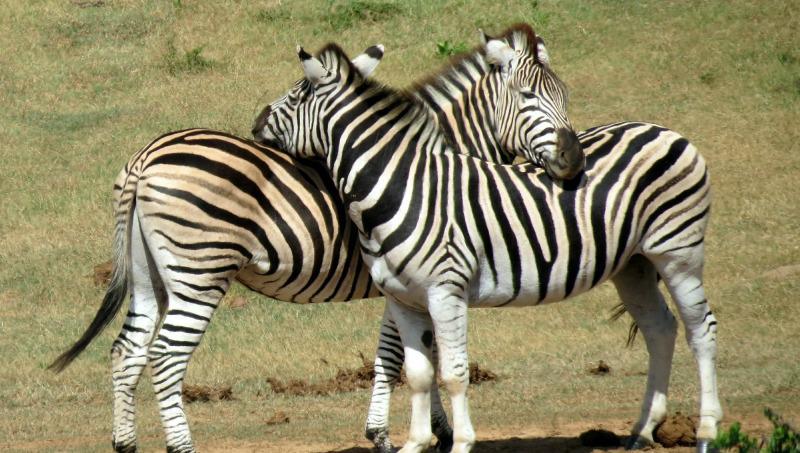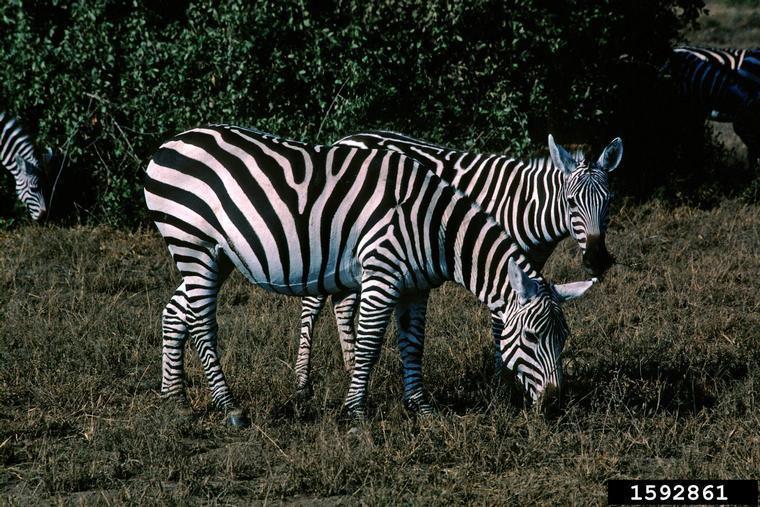The first image is the image on the left, the second image is the image on the right. Analyze the images presented: Is the assertion "One image shows two zebra standing in profile turned toward one another, each one with its head over the back of the other." valid? Answer yes or no. Yes. The first image is the image on the left, the second image is the image on the right. Examine the images to the left and right. Is the description "The left image contains no more than one zebra." accurate? Answer yes or no. No. 